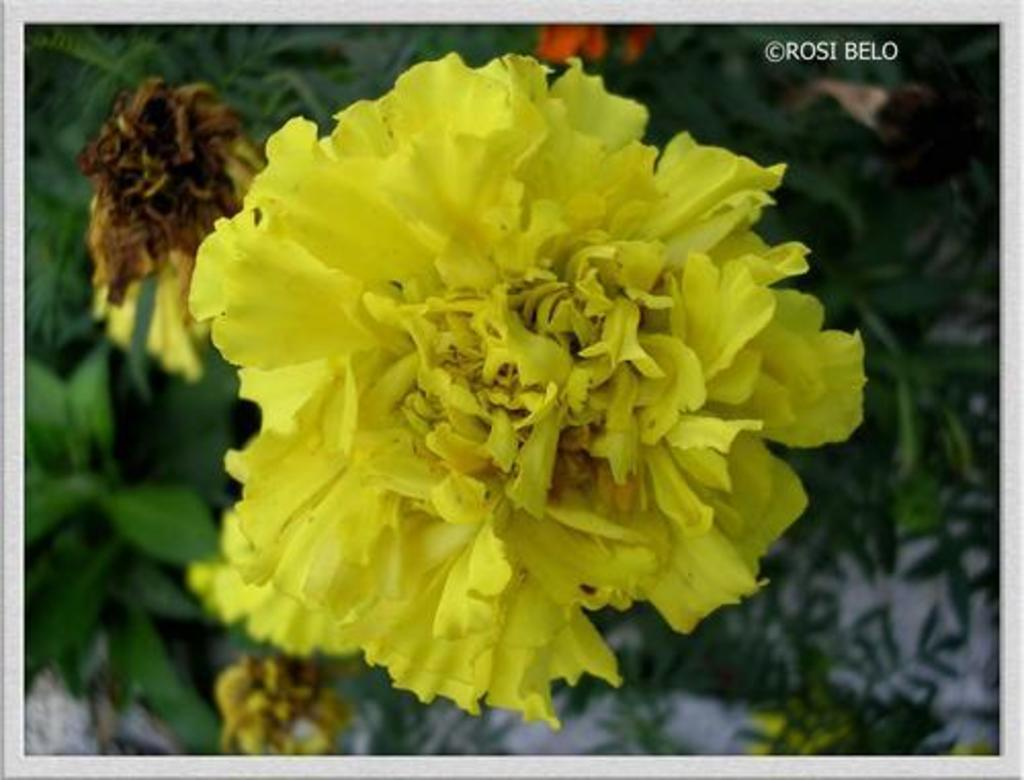What types of living organisms are in the image? The image contains plants and flowers. Can you describe the color of one of the flowers? One of the flowers is yellow. Is there any text or marking in the image? Yes, there is a watermark in the top right corner of the image. What type of cake is being served in the image? There is no cake present in the image; it features plants and flowers. How many wheels can be seen in the image? There are no wheels visible in the image. 